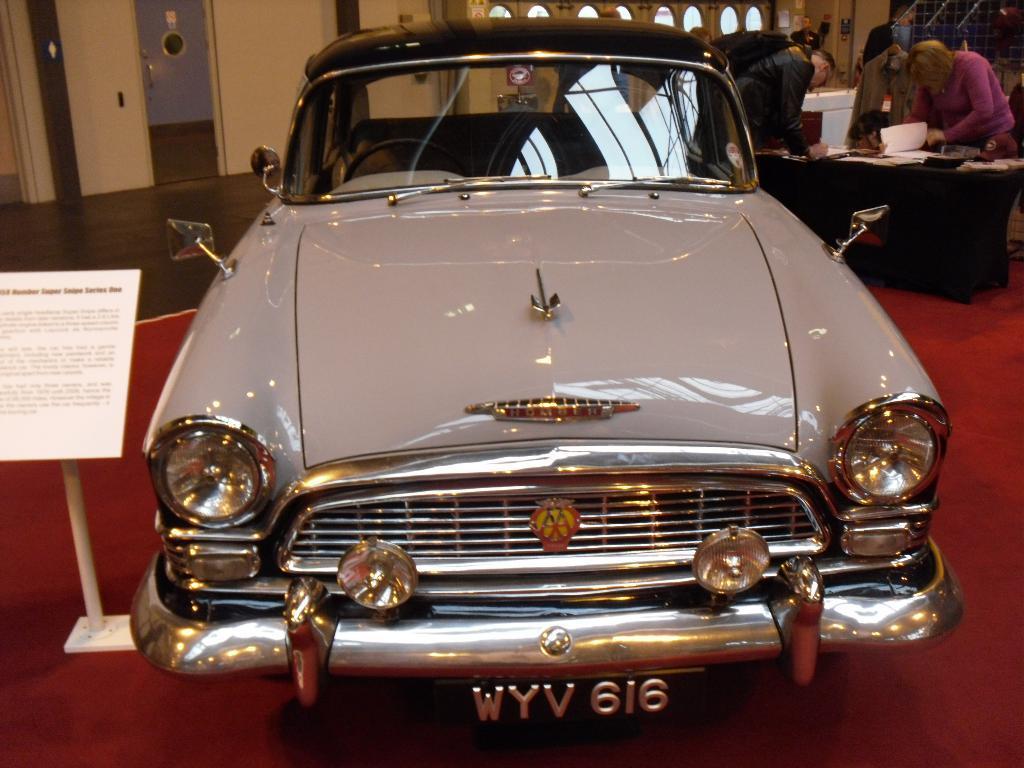Please provide a concise description of this image. In this image in front there is a car. Beside the car there is a stand board. At the bottom of the image there is a mat. On the right side of the image there is a table. On top of it there are papers and a few other objects. There are people. In the background of the image there is a wall. There is a glass door. 